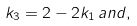<formula> <loc_0><loc_0><loc_500><loc_500>k _ { 3 } = 2 - 2 k _ { 1 } \, a n d ,</formula> 